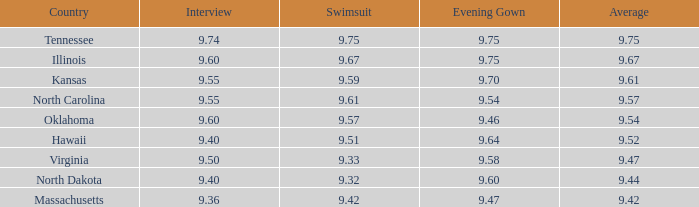What score did hawaii receive in the interview? 9.4. 